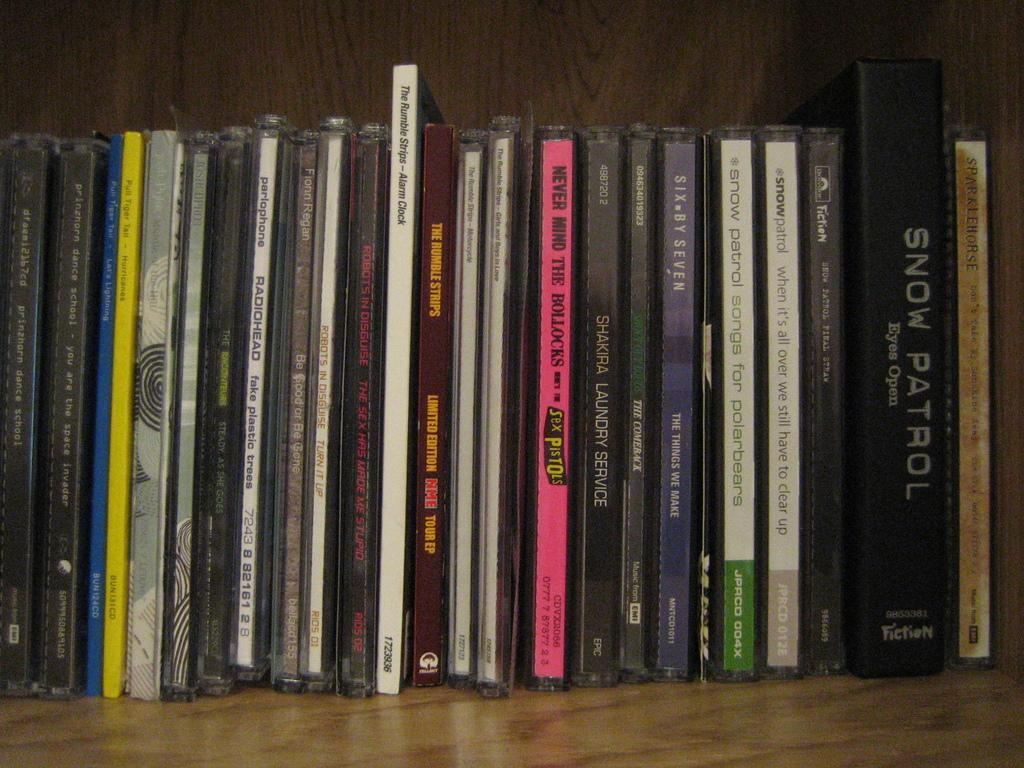Provide a one-sentence caption for the provided image. Snow Patron Eyes Open sits on a shelf next too other Snow Patrol movies. 